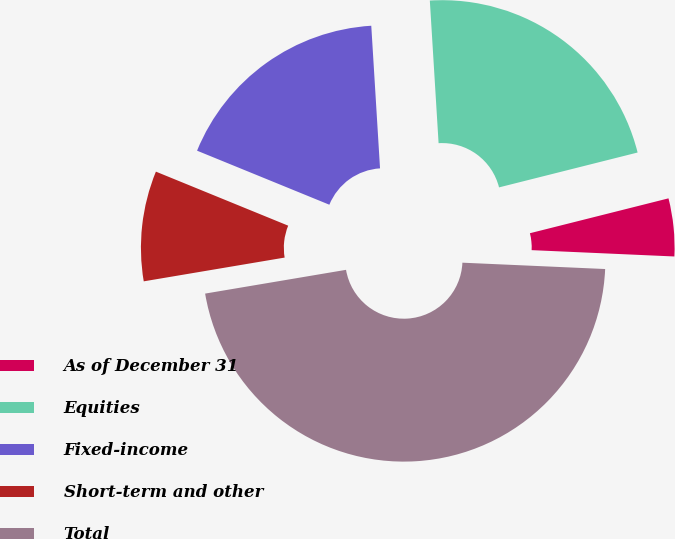<chart> <loc_0><loc_0><loc_500><loc_500><pie_chart><fcel>As of December 31<fcel>Equities<fcel>Fixed-income<fcel>Short-term and other<fcel>Total<nl><fcel>4.63%<fcel>22.05%<fcel>17.85%<fcel>8.83%<fcel>46.63%<nl></chart> 